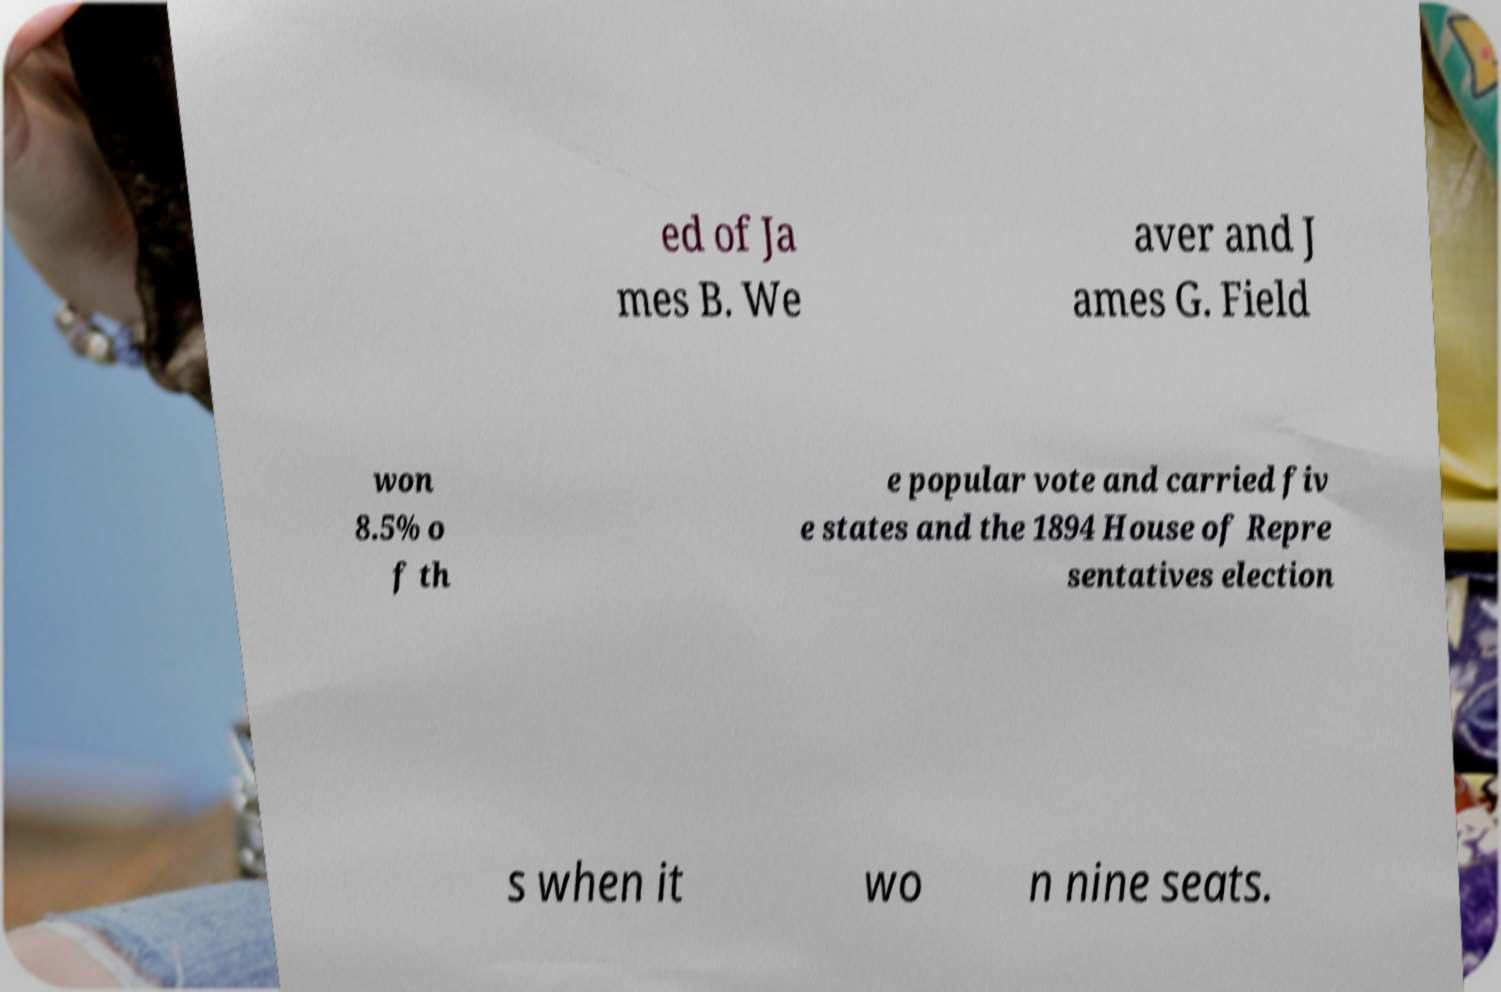What messages or text are displayed in this image? I need them in a readable, typed format. ed of Ja mes B. We aver and J ames G. Field won 8.5% o f th e popular vote and carried fiv e states and the 1894 House of Repre sentatives election s when it wo n nine seats. 